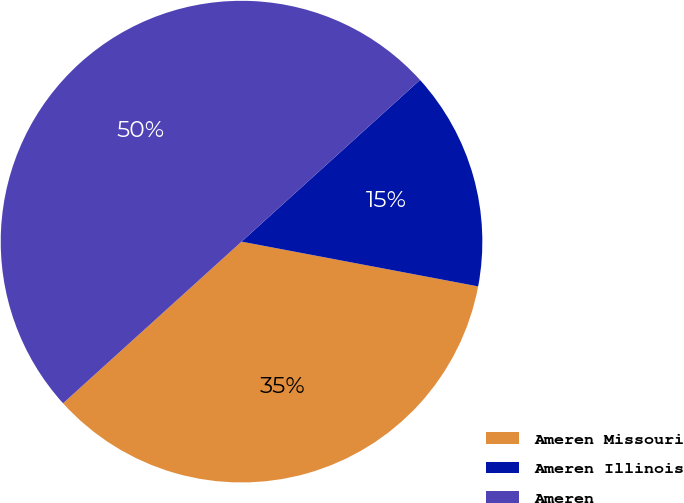Convert chart to OTSL. <chart><loc_0><loc_0><loc_500><loc_500><pie_chart><fcel>Ameren Missouri<fcel>Ameren Illinois<fcel>Ameren<nl><fcel>35.31%<fcel>14.69%<fcel>50.0%<nl></chart> 